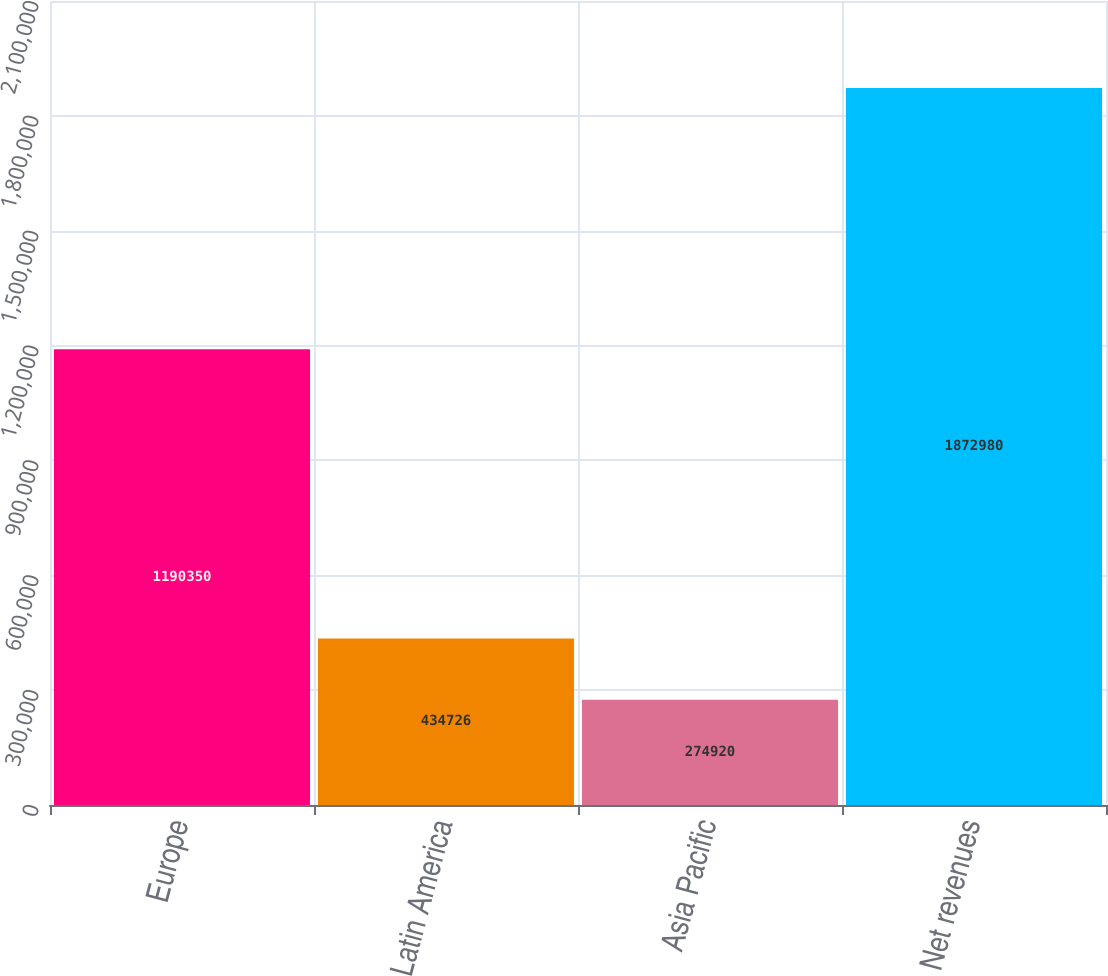Convert chart. <chart><loc_0><loc_0><loc_500><loc_500><bar_chart><fcel>Europe<fcel>Latin America<fcel>Asia Pacific<fcel>Net revenues<nl><fcel>1.19035e+06<fcel>434726<fcel>274920<fcel>1.87298e+06<nl></chart> 